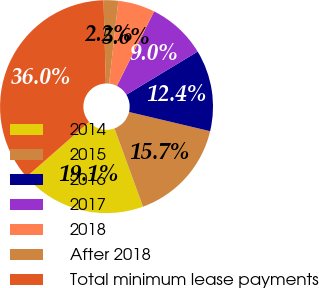Convert chart. <chart><loc_0><loc_0><loc_500><loc_500><pie_chart><fcel>2014<fcel>2015<fcel>2016<fcel>2017<fcel>2018<fcel>After 2018<fcel>Total minimum lease payments<nl><fcel>19.11%<fcel>15.73%<fcel>12.35%<fcel>8.98%<fcel>5.6%<fcel>2.22%<fcel>36.01%<nl></chart> 